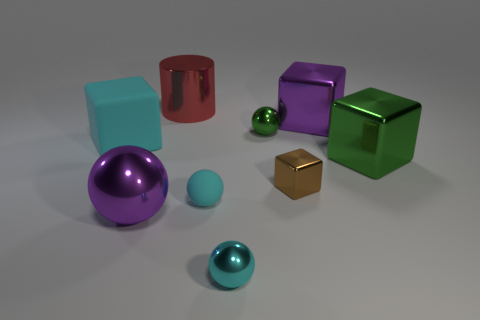Is there anything else that is the same shape as the large red metal thing?
Provide a short and direct response. No. Is the number of big shiny things in front of the green metallic block greater than the number of tiny cubes in front of the purple shiny cube?
Offer a terse response. No. There is a block that is on the left side of the large red shiny cylinder; what color is it?
Your answer should be very brief. Cyan. There is a metal block that is left of the big purple metallic block; is its size the same as the purple shiny object that is to the right of the small green ball?
Make the answer very short. No. What number of objects are tiny yellow rubber cylinders or big purple metallic objects?
Provide a short and direct response. 2. What material is the cyan sphere that is in front of the big purple object on the left side of the green ball?
Give a very brief answer. Metal. What number of large red things are the same shape as the tiny brown metallic object?
Offer a very short reply. 0. Is there a tiny ball that has the same color as the shiny cylinder?
Your answer should be compact. No. What number of objects are either metal balls on the left side of the large red metallic cylinder or matte objects to the right of the cyan block?
Ensure brevity in your answer.  2. There is a tiny rubber thing in front of the big cyan object; are there any small blocks that are in front of it?
Provide a succinct answer. No. 